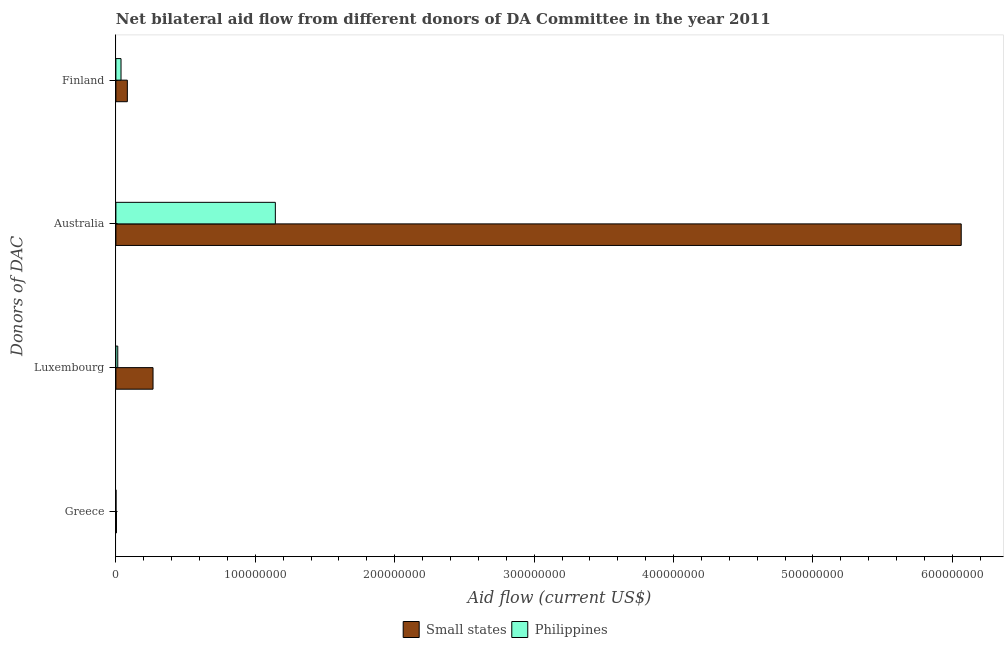Are the number of bars on each tick of the Y-axis equal?
Offer a very short reply. Yes. How many bars are there on the 2nd tick from the top?
Ensure brevity in your answer.  2. How many bars are there on the 1st tick from the bottom?
Give a very brief answer. 2. What is the label of the 2nd group of bars from the top?
Give a very brief answer. Australia. What is the amount of aid given by greece in Philippines?
Offer a very short reply. 8.00e+04. Across all countries, what is the maximum amount of aid given by luxembourg?
Your response must be concise. 2.66e+07. Across all countries, what is the minimum amount of aid given by australia?
Ensure brevity in your answer.  1.14e+08. In which country was the amount of aid given by luxembourg maximum?
Offer a terse response. Small states. In which country was the amount of aid given by australia minimum?
Your answer should be compact. Philippines. What is the total amount of aid given by luxembourg in the graph?
Offer a terse response. 2.80e+07. What is the difference between the amount of aid given by luxembourg in Small states and that in Philippines?
Ensure brevity in your answer.  2.53e+07. What is the difference between the amount of aid given by australia in Small states and the amount of aid given by luxembourg in Philippines?
Offer a very short reply. 6.05e+08. What is the average amount of aid given by australia per country?
Give a very brief answer. 3.60e+08. What is the difference between the amount of aid given by greece and amount of aid given by luxembourg in Small states?
Provide a succinct answer. -2.62e+07. In how many countries, is the amount of aid given by luxembourg greater than 520000000 US$?
Make the answer very short. 0. What is the ratio of the amount of aid given by greece in Philippines to that in Small states?
Ensure brevity in your answer.  0.21. Is the amount of aid given by greece in Small states less than that in Philippines?
Offer a very short reply. No. What is the difference between the highest and the second highest amount of aid given by australia?
Your response must be concise. 4.92e+08. What is the difference between the highest and the lowest amount of aid given by luxembourg?
Provide a short and direct response. 2.53e+07. In how many countries, is the amount of aid given by greece greater than the average amount of aid given by greece taken over all countries?
Offer a very short reply. 1. What does the 1st bar from the bottom in Greece represents?
Keep it short and to the point. Small states. How many bars are there?
Offer a very short reply. 8. How many countries are there in the graph?
Your answer should be very brief. 2. How many legend labels are there?
Keep it short and to the point. 2. How are the legend labels stacked?
Offer a very short reply. Horizontal. What is the title of the graph?
Your answer should be compact. Net bilateral aid flow from different donors of DA Committee in the year 2011. What is the label or title of the Y-axis?
Provide a succinct answer. Donors of DAC. What is the Aid flow (current US$) of Small states in Luxembourg?
Ensure brevity in your answer.  2.66e+07. What is the Aid flow (current US$) of Philippines in Luxembourg?
Make the answer very short. 1.35e+06. What is the Aid flow (current US$) of Small states in Australia?
Your answer should be very brief. 6.06e+08. What is the Aid flow (current US$) of Philippines in Australia?
Make the answer very short. 1.14e+08. What is the Aid flow (current US$) in Small states in Finland?
Keep it short and to the point. 8.22e+06. What is the Aid flow (current US$) in Philippines in Finland?
Provide a short and direct response. 3.68e+06. Across all Donors of DAC, what is the maximum Aid flow (current US$) of Small states?
Keep it short and to the point. 6.06e+08. Across all Donors of DAC, what is the maximum Aid flow (current US$) of Philippines?
Your response must be concise. 1.14e+08. What is the total Aid flow (current US$) in Small states in the graph?
Your answer should be compact. 6.42e+08. What is the total Aid flow (current US$) of Philippines in the graph?
Give a very brief answer. 1.19e+08. What is the difference between the Aid flow (current US$) of Small states in Greece and that in Luxembourg?
Provide a short and direct response. -2.62e+07. What is the difference between the Aid flow (current US$) of Philippines in Greece and that in Luxembourg?
Provide a short and direct response. -1.27e+06. What is the difference between the Aid flow (current US$) in Small states in Greece and that in Australia?
Keep it short and to the point. -6.06e+08. What is the difference between the Aid flow (current US$) of Philippines in Greece and that in Australia?
Your answer should be compact. -1.14e+08. What is the difference between the Aid flow (current US$) of Small states in Greece and that in Finland?
Offer a very short reply. -7.83e+06. What is the difference between the Aid flow (current US$) in Philippines in Greece and that in Finland?
Give a very brief answer. -3.60e+06. What is the difference between the Aid flow (current US$) in Small states in Luxembourg and that in Australia?
Keep it short and to the point. -5.80e+08. What is the difference between the Aid flow (current US$) in Philippines in Luxembourg and that in Australia?
Your answer should be compact. -1.13e+08. What is the difference between the Aid flow (current US$) in Small states in Luxembourg and that in Finland?
Your response must be concise. 1.84e+07. What is the difference between the Aid flow (current US$) in Philippines in Luxembourg and that in Finland?
Ensure brevity in your answer.  -2.33e+06. What is the difference between the Aid flow (current US$) of Small states in Australia and that in Finland?
Provide a succinct answer. 5.98e+08. What is the difference between the Aid flow (current US$) in Philippines in Australia and that in Finland?
Keep it short and to the point. 1.11e+08. What is the difference between the Aid flow (current US$) in Small states in Greece and the Aid flow (current US$) in Philippines in Luxembourg?
Offer a terse response. -9.60e+05. What is the difference between the Aid flow (current US$) in Small states in Greece and the Aid flow (current US$) in Philippines in Australia?
Offer a terse response. -1.14e+08. What is the difference between the Aid flow (current US$) in Small states in Greece and the Aid flow (current US$) in Philippines in Finland?
Your answer should be very brief. -3.29e+06. What is the difference between the Aid flow (current US$) of Small states in Luxembourg and the Aid flow (current US$) of Philippines in Australia?
Offer a very short reply. -8.77e+07. What is the difference between the Aid flow (current US$) of Small states in Luxembourg and the Aid flow (current US$) of Philippines in Finland?
Your answer should be compact. 2.30e+07. What is the difference between the Aid flow (current US$) of Small states in Australia and the Aid flow (current US$) of Philippines in Finland?
Give a very brief answer. 6.03e+08. What is the average Aid flow (current US$) in Small states per Donors of DAC?
Provide a succinct answer. 1.60e+08. What is the average Aid flow (current US$) in Philippines per Donors of DAC?
Offer a terse response. 2.99e+07. What is the difference between the Aid flow (current US$) in Small states and Aid flow (current US$) in Philippines in Greece?
Offer a very short reply. 3.10e+05. What is the difference between the Aid flow (current US$) in Small states and Aid flow (current US$) in Philippines in Luxembourg?
Offer a very short reply. 2.53e+07. What is the difference between the Aid flow (current US$) of Small states and Aid flow (current US$) of Philippines in Australia?
Provide a short and direct response. 4.92e+08. What is the difference between the Aid flow (current US$) in Small states and Aid flow (current US$) in Philippines in Finland?
Offer a terse response. 4.54e+06. What is the ratio of the Aid flow (current US$) of Small states in Greece to that in Luxembourg?
Keep it short and to the point. 0.01. What is the ratio of the Aid flow (current US$) in Philippines in Greece to that in Luxembourg?
Ensure brevity in your answer.  0.06. What is the ratio of the Aid flow (current US$) in Small states in Greece to that in Australia?
Your answer should be compact. 0. What is the ratio of the Aid flow (current US$) in Philippines in Greece to that in Australia?
Your answer should be compact. 0. What is the ratio of the Aid flow (current US$) in Small states in Greece to that in Finland?
Ensure brevity in your answer.  0.05. What is the ratio of the Aid flow (current US$) in Philippines in Greece to that in Finland?
Your response must be concise. 0.02. What is the ratio of the Aid flow (current US$) of Small states in Luxembourg to that in Australia?
Keep it short and to the point. 0.04. What is the ratio of the Aid flow (current US$) in Philippines in Luxembourg to that in Australia?
Your response must be concise. 0.01. What is the ratio of the Aid flow (current US$) in Small states in Luxembourg to that in Finland?
Your answer should be compact. 3.24. What is the ratio of the Aid flow (current US$) in Philippines in Luxembourg to that in Finland?
Your response must be concise. 0.37. What is the ratio of the Aid flow (current US$) of Small states in Australia to that in Finland?
Offer a terse response. 73.77. What is the ratio of the Aid flow (current US$) of Philippines in Australia to that in Finland?
Keep it short and to the point. 31.08. What is the difference between the highest and the second highest Aid flow (current US$) in Small states?
Ensure brevity in your answer.  5.80e+08. What is the difference between the highest and the second highest Aid flow (current US$) of Philippines?
Your answer should be very brief. 1.11e+08. What is the difference between the highest and the lowest Aid flow (current US$) of Small states?
Make the answer very short. 6.06e+08. What is the difference between the highest and the lowest Aid flow (current US$) of Philippines?
Ensure brevity in your answer.  1.14e+08. 